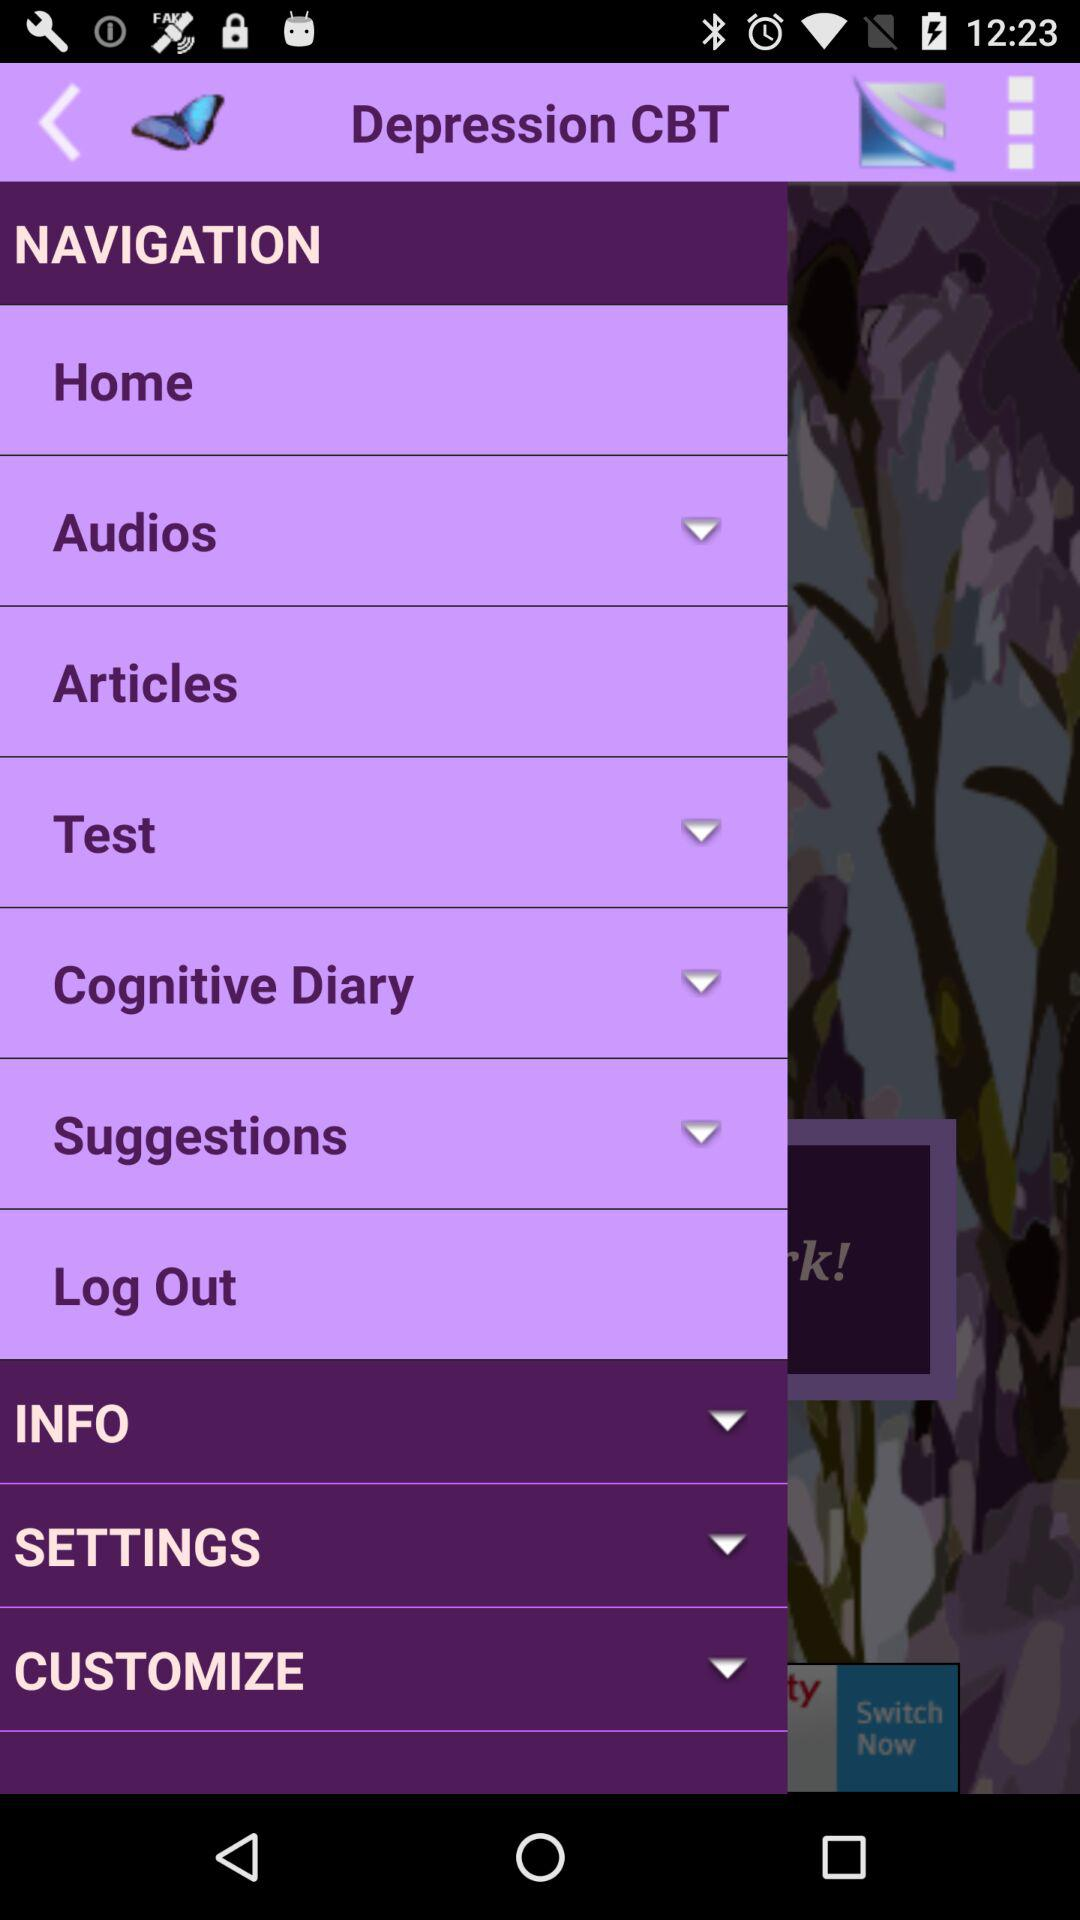What is the name of the application? The application name is "Depression CBT". 